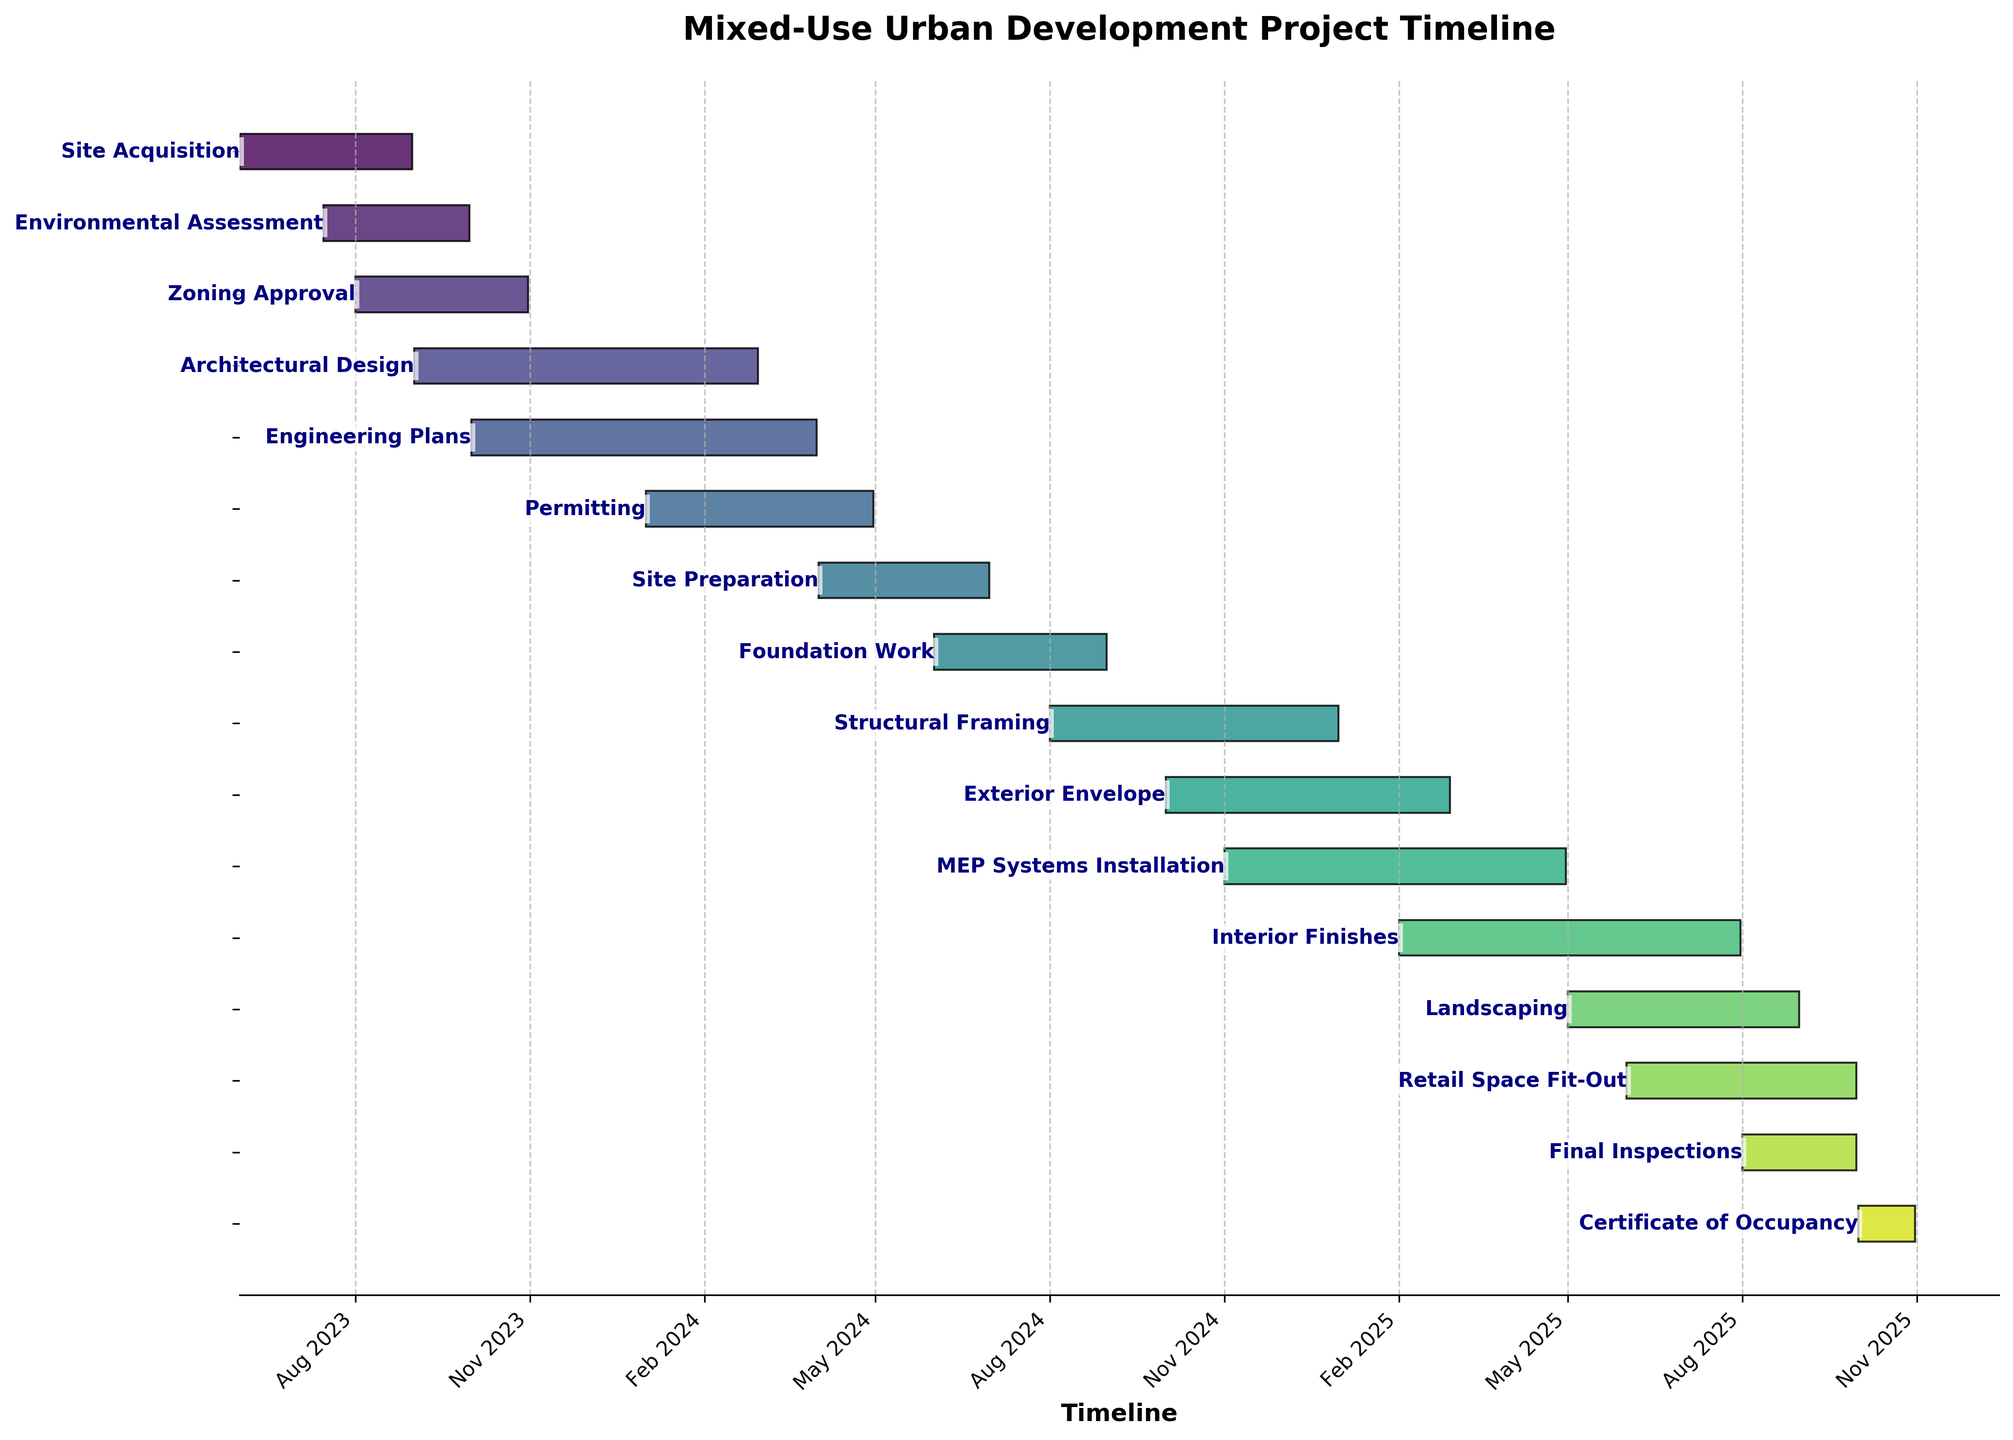What's the title of the Gantt Chart? The title is usually the text at the top of the chart. It summarizes what the timeline represents. In this case, it would be the text shown prominently at the top of the figure.
Answer: Mixed-Use Urban Development Project Timeline What is the duration of the longest task in the timeline? The longest task can be found by comparing the duration of each task, which is calculated as the difference between the end date and the start date. The task with the maximum duration is the longest.
Answer: Architectural Design (6 months) Which tasks are scheduled to start in January 2024? To find tasks starting in January 2024, look for tasks whose start date falls within this month. The task will be identified by observing the Gantt Chart timeline axis and the corresponding bar positions.
Answer: Permitting What is the overall project timeline duration, from the earliest start date to the latest end date? Identify the earliest start date and the latest end date from the chart. Subtract the earliest start date from the latest end date to get the overall project timeline duration.
Answer: 2 years and 5 months How long is the gap between the end of 'Foundation Work' and the start of 'Structural Framing'? Find the end date of 'Foundation Work' and the start date of 'Structural Framing'. Calculate the gap as the difference between these two dates.
Answer: No gap (they overlap in August 2024) Which phase overlaps with both 'Environmental Assessment' and 'Zoning Approval'? Identify the time periods for 'Environmental Assessment' and 'Zoning Approval', then find any other phase that has dates within or overlapping these periods.
Answer: Zoning Approval When does 'MEP Systems Installation' complete, and what is its duration? Locate 'MEP Systems Installation' on the chart, find its end date and calculate the duration by subtracting the start date from the end date.
Answer: April 30, 2025; 6 months Which tasks are concurrent with the 'Retail Space Fit-Out' phase? Identify the duration of 'Retail Space Fit-Out' on the chart. Then find any tasks whose timelines overlap with this duration.
Answer: Interior Finishes, Landscaping, Final Inspections What phase follows immediately after 'Final Inspections'? Look for the task which starts immediately after the end of 'Final Inspections' in the timeline.
Answer: Certificate of Occupancy Which two phases have the largest overlap in their durations? Examine all phases and identify any two whose timelines overlap the most in terms of duration.
Answer: Architectural Design and Engineering Plans 